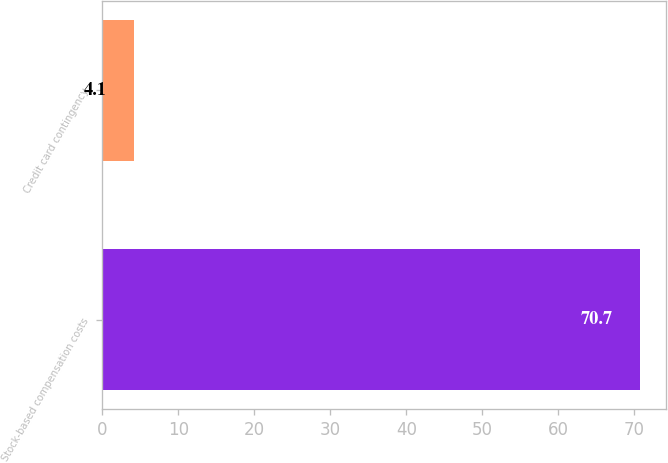Convert chart to OTSL. <chart><loc_0><loc_0><loc_500><loc_500><bar_chart><fcel>Stock-based compensation costs<fcel>Credit card contingency<nl><fcel>70.7<fcel>4.1<nl></chart> 